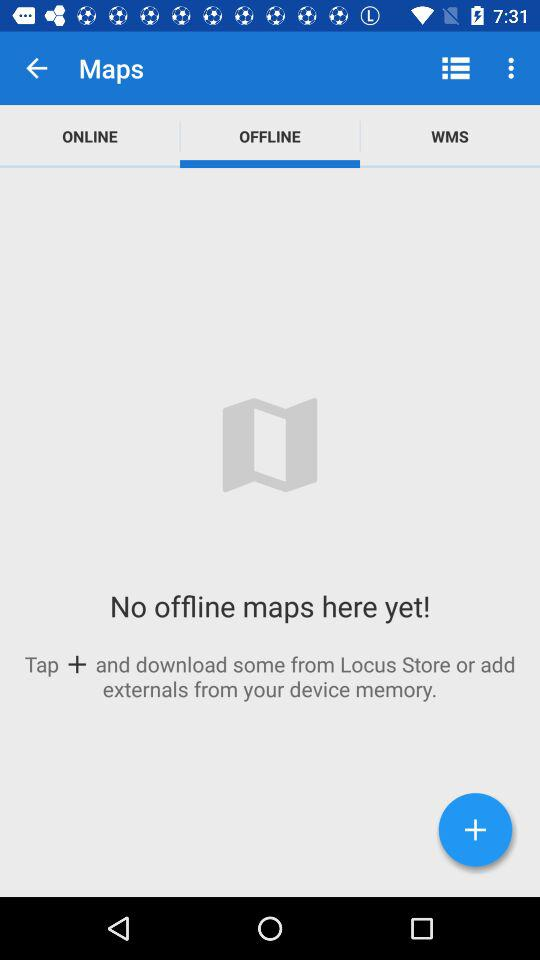Which tab is selected? The selected tab is "OFFLINE". 